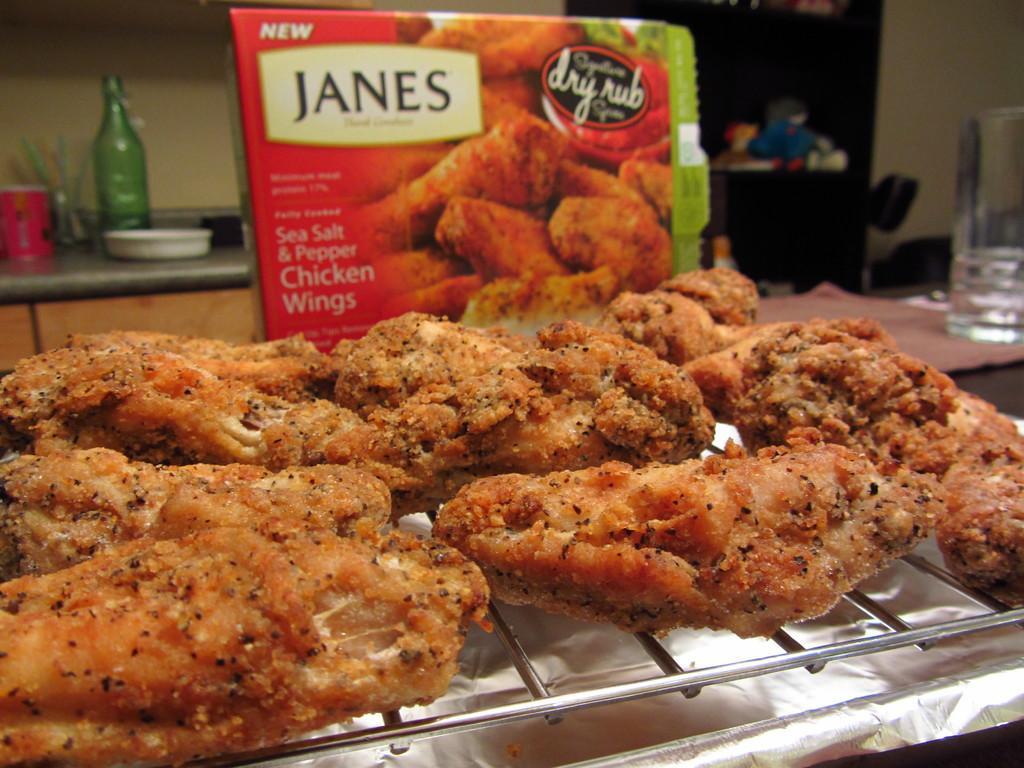Could you give a brief overview of what you see in this image? In this image we can see some food item on the grill, there is a bottle, glass, bowl, and an object on the kitchen slab, there is a glass on the table, also we can see the wall, a box with text and pictures on it, and there are some objects in the closet. 